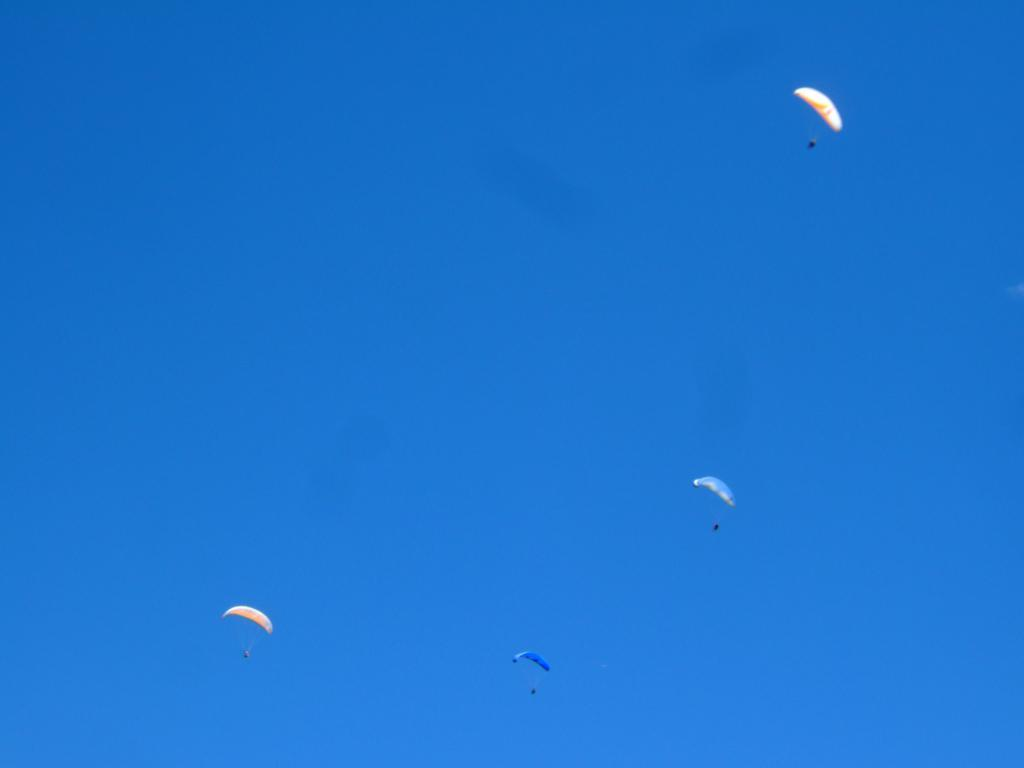What can be seen in the sky in the image? There are parachutes visible in the sky in the image. What type of screw is being used to assemble the playground in the image? There is no playground or screw present in the image; it only features parachutes in the sky. 